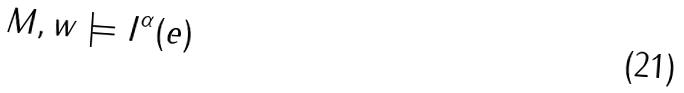Convert formula to latex. <formula><loc_0><loc_0><loc_500><loc_500>M , w \models I ^ { \alpha } ( e )</formula> 